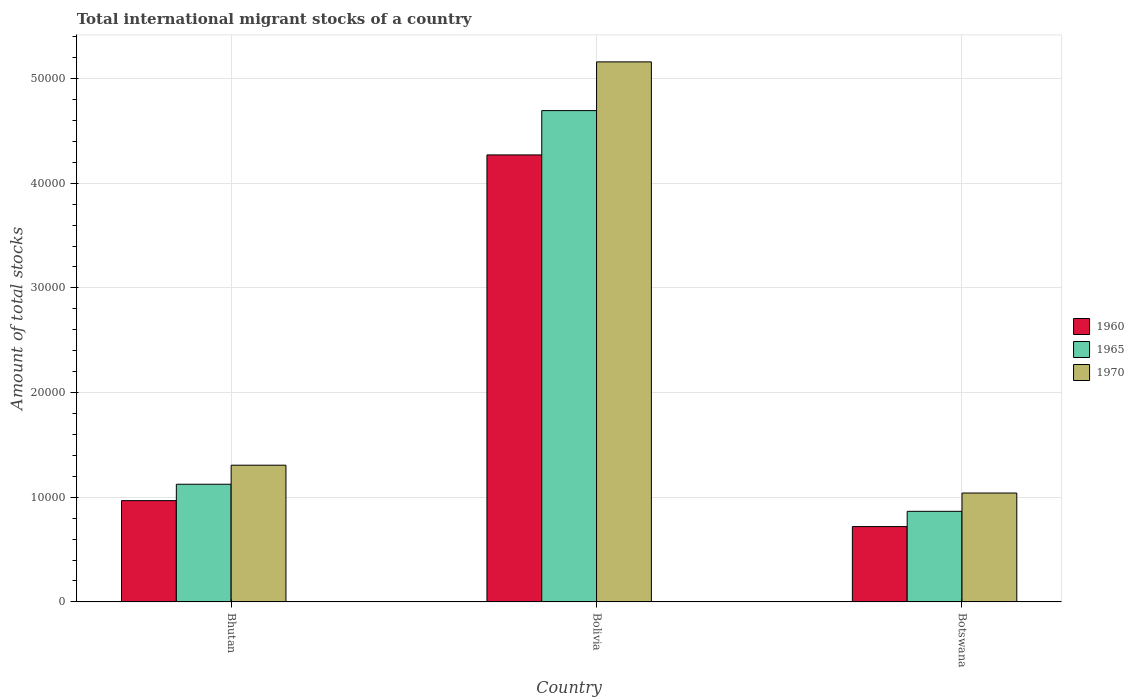Are the number of bars per tick equal to the number of legend labels?
Offer a very short reply. Yes. Are the number of bars on each tick of the X-axis equal?
Provide a succinct answer. Yes. How many bars are there on the 2nd tick from the left?
Offer a terse response. 3. In how many cases, is the number of bars for a given country not equal to the number of legend labels?
Provide a succinct answer. 0. What is the amount of total stocks in in 1960 in Bhutan?
Provide a short and direct response. 9676. Across all countries, what is the maximum amount of total stocks in in 1960?
Your answer should be very brief. 4.27e+04. Across all countries, what is the minimum amount of total stocks in in 1960?
Your answer should be compact. 7199. In which country was the amount of total stocks in in 1965 minimum?
Offer a terse response. Botswana. What is the total amount of total stocks in in 1960 in the graph?
Provide a short and direct response. 5.96e+04. What is the difference between the amount of total stocks in in 1960 in Bhutan and that in Bolivia?
Keep it short and to the point. -3.30e+04. What is the difference between the amount of total stocks in in 1960 in Bolivia and the amount of total stocks in in 1965 in Bhutan?
Offer a very short reply. 3.15e+04. What is the average amount of total stocks in in 1965 per country?
Give a very brief answer. 2.23e+04. What is the difference between the amount of total stocks in of/in 1965 and amount of total stocks in of/in 1970 in Bolivia?
Your response must be concise. -4655. What is the ratio of the amount of total stocks in in 1970 in Bhutan to that in Bolivia?
Make the answer very short. 0.25. Is the amount of total stocks in in 1970 in Bhutan less than that in Botswana?
Provide a short and direct response. No. Is the difference between the amount of total stocks in in 1965 in Bhutan and Botswana greater than the difference between the amount of total stocks in in 1970 in Bhutan and Botswana?
Keep it short and to the point. No. What is the difference between the highest and the second highest amount of total stocks in in 1965?
Provide a short and direct response. 3.57e+04. What is the difference between the highest and the lowest amount of total stocks in in 1965?
Give a very brief answer. 3.83e+04. In how many countries, is the amount of total stocks in in 1960 greater than the average amount of total stocks in in 1960 taken over all countries?
Provide a short and direct response. 1. Is the sum of the amount of total stocks in in 1965 in Bolivia and Botswana greater than the maximum amount of total stocks in in 1970 across all countries?
Your answer should be compact. Yes. What does the 2nd bar from the left in Bhutan represents?
Ensure brevity in your answer.  1965. What does the 2nd bar from the right in Bolivia represents?
Keep it short and to the point. 1965. Is it the case that in every country, the sum of the amount of total stocks in in 1965 and amount of total stocks in in 1970 is greater than the amount of total stocks in in 1960?
Your response must be concise. Yes. Are all the bars in the graph horizontal?
Make the answer very short. No. Does the graph contain grids?
Offer a very short reply. Yes. Where does the legend appear in the graph?
Keep it short and to the point. Center right. How are the legend labels stacked?
Ensure brevity in your answer.  Vertical. What is the title of the graph?
Your response must be concise. Total international migrant stocks of a country. Does "1986" appear as one of the legend labels in the graph?
Provide a succinct answer. No. What is the label or title of the X-axis?
Keep it short and to the point. Country. What is the label or title of the Y-axis?
Your answer should be very brief. Amount of total stocks. What is the Amount of total stocks of 1960 in Bhutan?
Provide a short and direct response. 9676. What is the Amount of total stocks of 1965 in Bhutan?
Offer a terse response. 1.12e+04. What is the Amount of total stocks in 1970 in Bhutan?
Your answer should be compact. 1.31e+04. What is the Amount of total stocks in 1960 in Bolivia?
Keep it short and to the point. 4.27e+04. What is the Amount of total stocks in 1965 in Bolivia?
Your response must be concise. 4.69e+04. What is the Amount of total stocks of 1970 in Bolivia?
Give a very brief answer. 5.16e+04. What is the Amount of total stocks of 1960 in Botswana?
Make the answer very short. 7199. What is the Amount of total stocks in 1965 in Botswana?
Ensure brevity in your answer.  8655. What is the Amount of total stocks of 1970 in Botswana?
Keep it short and to the point. 1.04e+04. Across all countries, what is the maximum Amount of total stocks in 1960?
Offer a terse response. 4.27e+04. Across all countries, what is the maximum Amount of total stocks of 1965?
Provide a short and direct response. 4.69e+04. Across all countries, what is the maximum Amount of total stocks in 1970?
Give a very brief answer. 5.16e+04. Across all countries, what is the minimum Amount of total stocks in 1960?
Keep it short and to the point. 7199. Across all countries, what is the minimum Amount of total stocks in 1965?
Make the answer very short. 8655. Across all countries, what is the minimum Amount of total stocks in 1970?
Offer a very short reply. 1.04e+04. What is the total Amount of total stocks of 1960 in the graph?
Ensure brevity in your answer.  5.96e+04. What is the total Amount of total stocks of 1965 in the graph?
Offer a terse response. 6.68e+04. What is the total Amount of total stocks in 1970 in the graph?
Your response must be concise. 7.51e+04. What is the difference between the Amount of total stocks in 1960 in Bhutan and that in Bolivia?
Your response must be concise. -3.30e+04. What is the difference between the Amount of total stocks of 1965 in Bhutan and that in Bolivia?
Give a very brief answer. -3.57e+04. What is the difference between the Amount of total stocks in 1970 in Bhutan and that in Bolivia?
Keep it short and to the point. -3.85e+04. What is the difference between the Amount of total stocks in 1960 in Bhutan and that in Botswana?
Make the answer very short. 2477. What is the difference between the Amount of total stocks in 1965 in Bhutan and that in Botswana?
Give a very brief answer. 2588. What is the difference between the Amount of total stocks of 1970 in Bhutan and that in Botswana?
Make the answer very short. 2659. What is the difference between the Amount of total stocks in 1960 in Bolivia and that in Botswana?
Make the answer very short. 3.55e+04. What is the difference between the Amount of total stocks in 1965 in Bolivia and that in Botswana?
Your answer should be compact. 3.83e+04. What is the difference between the Amount of total stocks of 1970 in Bolivia and that in Botswana?
Ensure brevity in your answer.  4.12e+04. What is the difference between the Amount of total stocks in 1960 in Bhutan and the Amount of total stocks in 1965 in Bolivia?
Your answer should be compact. -3.73e+04. What is the difference between the Amount of total stocks of 1960 in Bhutan and the Amount of total stocks of 1970 in Bolivia?
Provide a short and direct response. -4.19e+04. What is the difference between the Amount of total stocks in 1965 in Bhutan and the Amount of total stocks in 1970 in Bolivia?
Keep it short and to the point. -4.04e+04. What is the difference between the Amount of total stocks of 1960 in Bhutan and the Amount of total stocks of 1965 in Botswana?
Your answer should be compact. 1021. What is the difference between the Amount of total stocks in 1960 in Bhutan and the Amount of total stocks in 1970 in Botswana?
Provide a short and direct response. -728. What is the difference between the Amount of total stocks of 1965 in Bhutan and the Amount of total stocks of 1970 in Botswana?
Make the answer very short. 839. What is the difference between the Amount of total stocks of 1960 in Bolivia and the Amount of total stocks of 1965 in Botswana?
Ensure brevity in your answer.  3.41e+04. What is the difference between the Amount of total stocks in 1960 in Bolivia and the Amount of total stocks in 1970 in Botswana?
Your response must be concise. 3.23e+04. What is the difference between the Amount of total stocks in 1965 in Bolivia and the Amount of total stocks in 1970 in Botswana?
Make the answer very short. 3.65e+04. What is the average Amount of total stocks of 1960 per country?
Offer a very short reply. 1.99e+04. What is the average Amount of total stocks of 1965 per country?
Provide a short and direct response. 2.23e+04. What is the average Amount of total stocks in 1970 per country?
Keep it short and to the point. 2.50e+04. What is the difference between the Amount of total stocks in 1960 and Amount of total stocks in 1965 in Bhutan?
Give a very brief answer. -1567. What is the difference between the Amount of total stocks of 1960 and Amount of total stocks of 1970 in Bhutan?
Give a very brief answer. -3387. What is the difference between the Amount of total stocks in 1965 and Amount of total stocks in 1970 in Bhutan?
Make the answer very short. -1820. What is the difference between the Amount of total stocks in 1960 and Amount of total stocks in 1965 in Bolivia?
Make the answer very short. -4235. What is the difference between the Amount of total stocks in 1960 and Amount of total stocks in 1970 in Bolivia?
Offer a terse response. -8890. What is the difference between the Amount of total stocks of 1965 and Amount of total stocks of 1970 in Bolivia?
Offer a very short reply. -4655. What is the difference between the Amount of total stocks in 1960 and Amount of total stocks in 1965 in Botswana?
Ensure brevity in your answer.  -1456. What is the difference between the Amount of total stocks of 1960 and Amount of total stocks of 1970 in Botswana?
Provide a short and direct response. -3205. What is the difference between the Amount of total stocks in 1965 and Amount of total stocks in 1970 in Botswana?
Provide a short and direct response. -1749. What is the ratio of the Amount of total stocks of 1960 in Bhutan to that in Bolivia?
Your response must be concise. 0.23. What is the ratio of the Amount of total stocks in 1965 in Bhutan to that in Bolivia?
Your answer should be compact. 0.24. What is the ratio of the Amount of total stocks in 1970 in Bhutan to that in Bolivia?
Provide a succinct answer. 0.25. What is the ratio of the Amount of total stocks in 1960 in Bhutan to that in Botswana?
Provide a succinct answer. 1.34. What is the ratio of the Amount of total stocks of 1965 in Bhutan to that in Botswana?
Your answer should be very brief. 1.3. What is the ratio of the Amount of total stocks in 1970 in Bhutan to that in Botswana?
Offer a very short reply. 1.26. What is the ratio of the Amount of total stocks in 1960 in Bolivia to that in Botswana?
Provide a succinct answer. 5.93. What is the ratio of the Amount of total stocks of 1965 in Bolivia to that in Botswana?
Ensure brevity in your answer.  5.42. What is the ratio of the Amount of total stocks of 1970 in Bolivia to that in Botswana?
Your answer should be compact. 4.96. What is the difference between the highest and the second highest Amount of total stocks in 1960?
Provide a short and direct response. 3.30e+04. What is the difference between the highest and the second highest Amount of total stocks in 1965?
Your response must be concise. 3.57e+04. What is the difference between the highest and the second highest Amount of total stocks in 1970?
Your answer should be compact. 3.85e+04. What is the difference between the highest and the lowest Amount of total stocks of 1960?
Provide a short and direct response. 3.55e+04. What is the difference between the highest and the lowest Amount of total stocks of 1965?
Ensure brevity in your answer.  3.83e+04. What is the difference between the highest and the lowest Amount of total stocks of 1970?
Keep it short and to the point. 4.12e+04. 